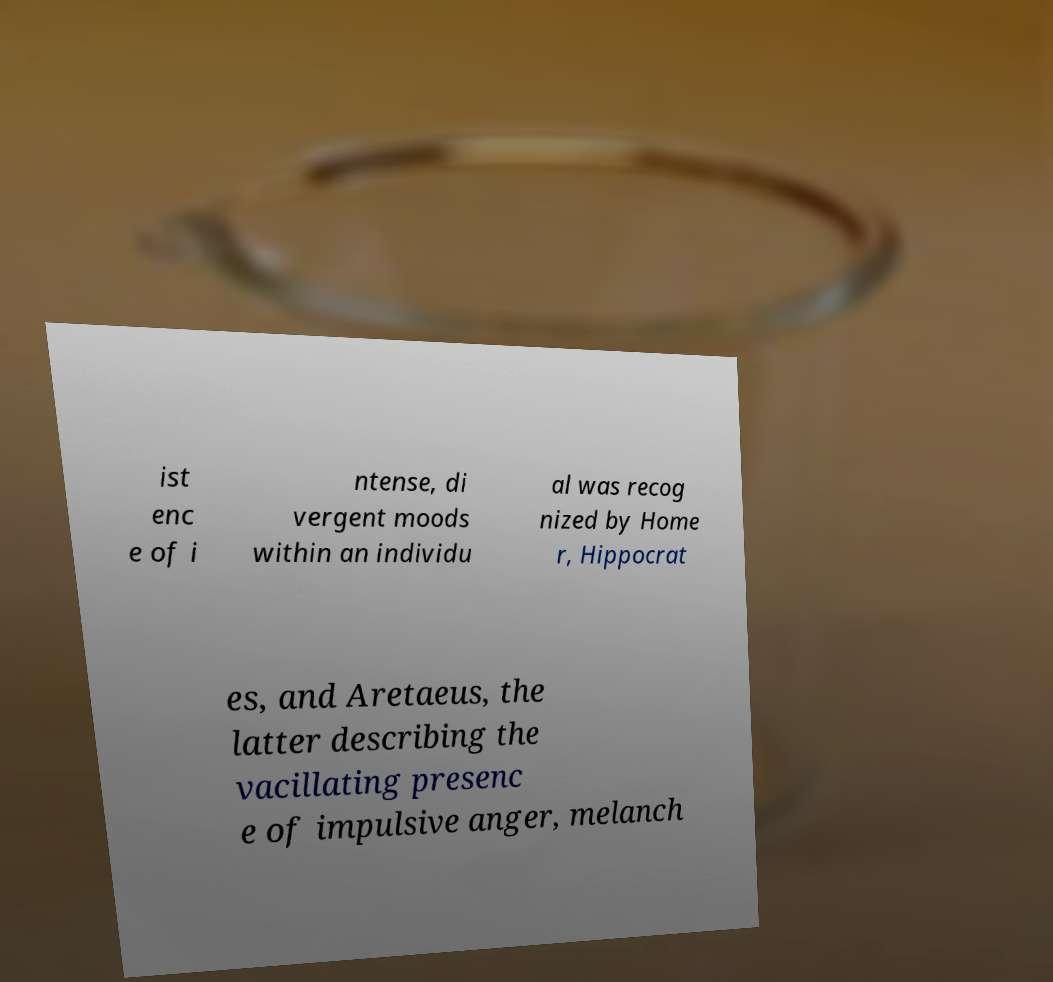I need the written content from this picture converted into text. Can you do that? ist enc e of i ntense, di vergent moods within an individu al was recog nized by Home r, Hippocrat es, and Aretaeus, the latter describing the vacillating presenc e of impulsive anger, melanch 